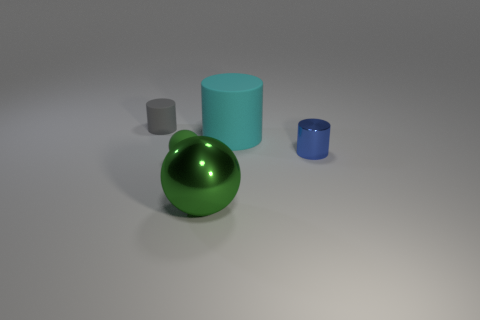What number of tiny gray cylinders are made of the same material as the small green thing?
Provide a succinct answer. 1. There is a big object that is behind the green sphere that is in front of the green matte object; is there a small cylinder left of it?
Offer a terse response. Yes. What shape is the tiny shiny thing?
Your answer should be compact. Cylinder. Do the small cylinder that is on the right side of the gray matte thing and the cyan thing to the right of the tiny gray matte thing have the same material?
Offer a terse response. No. What number of large metallic things are the same color as the matte sphere?
Your answer should be very brief. 1. The object that is on the right side of the green matte thing and to the left of the big rubber cylinder has what shape?
Provide a short and direct response. Sphere. What color is the matte object that is both behind the small green object and on the right side of the tiny gray matte cylinder?
Provide a short and direct response. Cyan. Are there more objects that are left of the tiny blue cylinder than small blue metallic objects on the left side of the large cyan rubber thing?
Your answer should be compact. Yes. There is a small cylinder that is behind the tiny blue object; what is its color?
Keep it short and to the point. Gray. Is the shape of the tiny object that is behind the metal cylinder the same as the green object that is in front of the tiny green ball?
Your answer should be compact. No. 